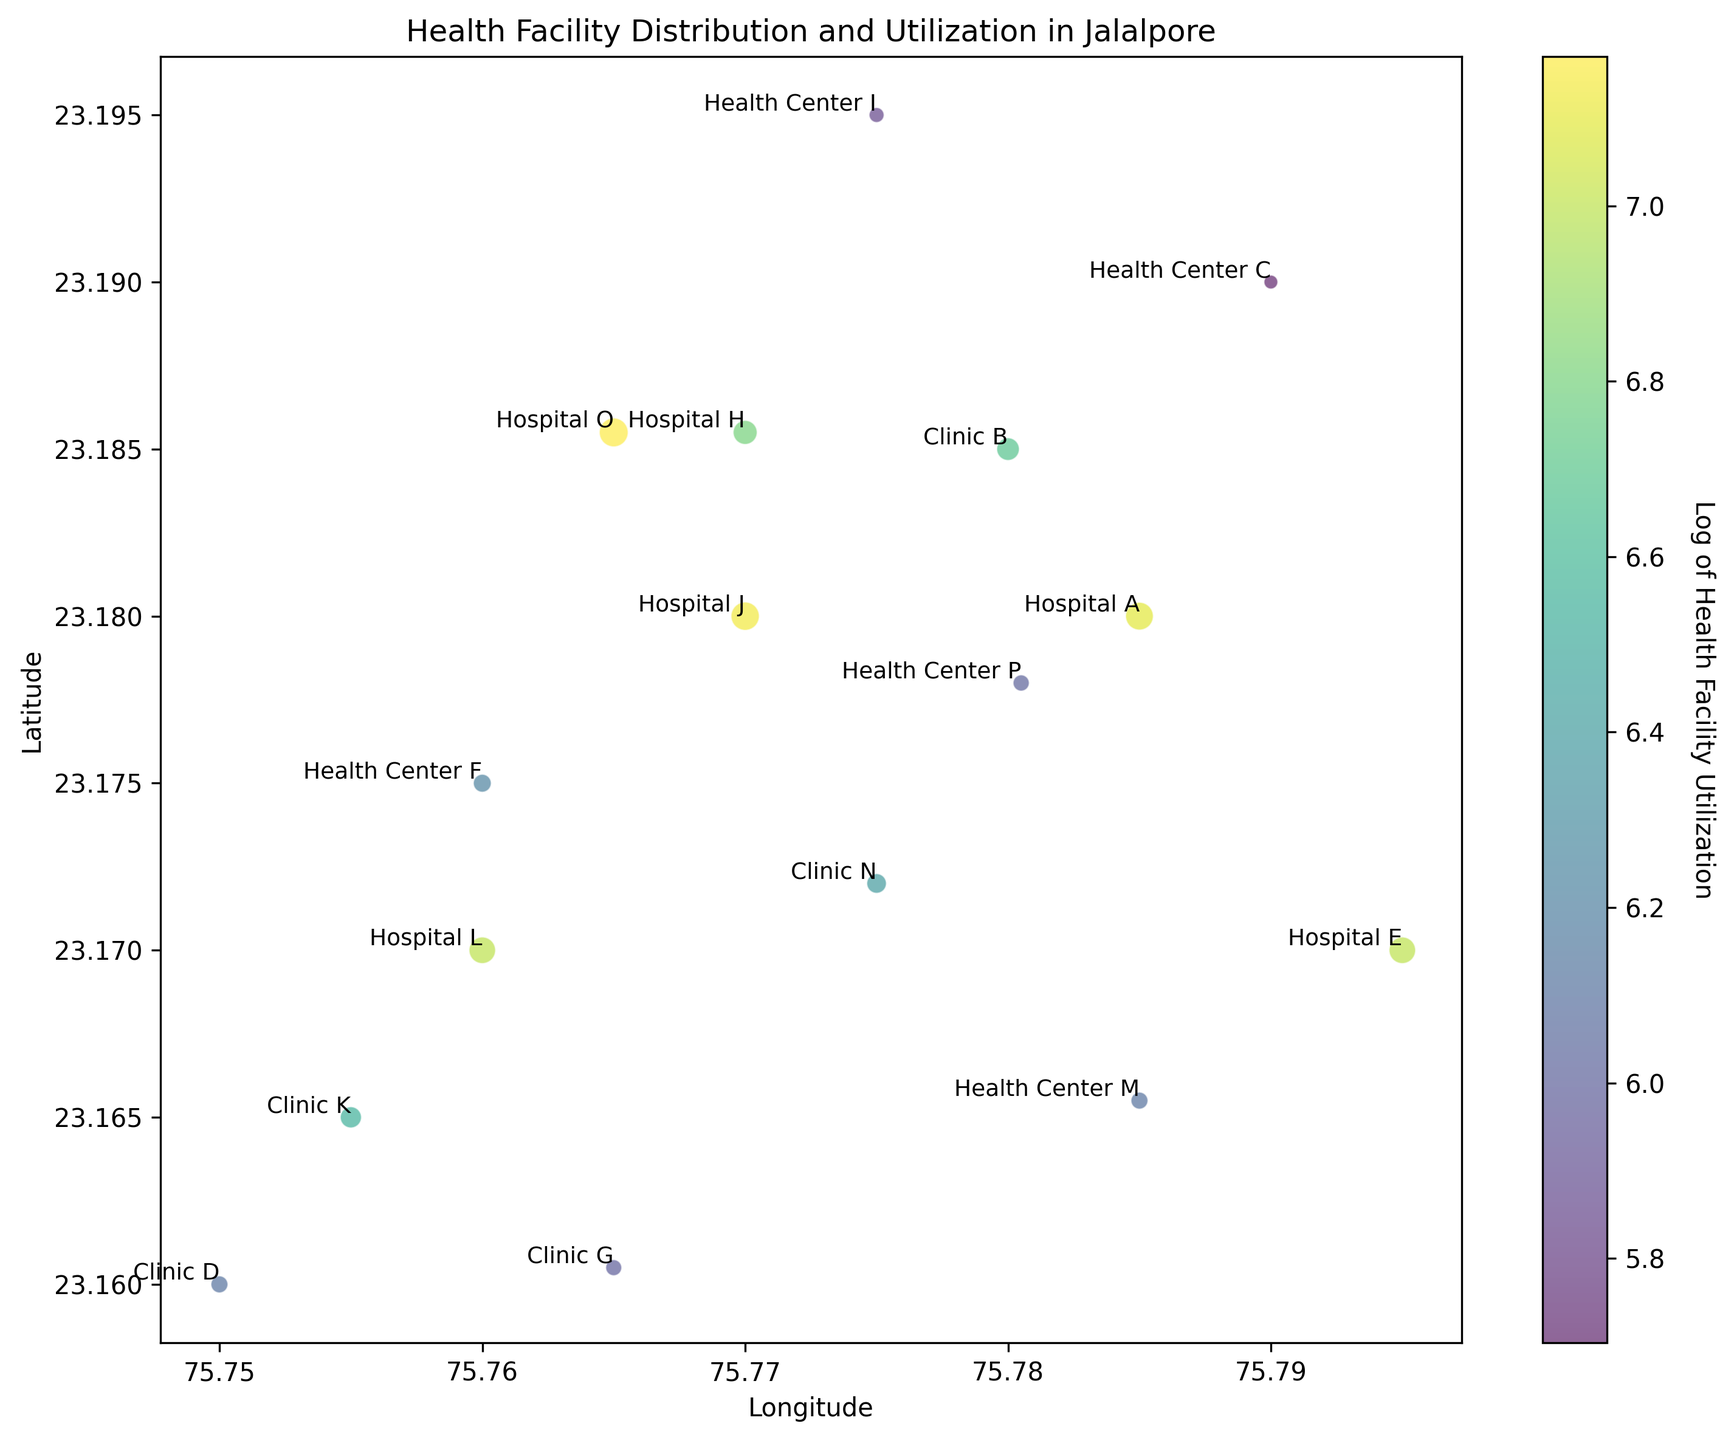What is the range of latitudes covered by the health facilities? To find the range, identify the lowest and highest latitude values from the facilities. The lowest latitude is 23.1600 (Clinic D) and the highest is 23.1950 (Health Center I). The range is 23.1950 - 23.1600 = 0.035
Answer: 0.035 Which facility has the highest utilization? Look for the facility with the largest circle and a color indicating the highest utilization on the heatmap. Hospital O has the highest utilization at 1300.
Answer: Hospital O How do Hospital A and Clinic B compare in terms of utilization? Find the circles representing Hospital A and Clinic B. Compare their sizes and color intensities. Hospital A has a utilization of 1200, while Clinic B has 800.
Answer: Hospital A has higher utilization than Clinic B What is the average utilization of all health centers? Sum up the utilization values of all health centers (300 + 500 + 350 + 450 + 410 = 2010) and divide by the number of health centers (5). The average utilization is 2010 / 5 = 402.
Answer: 402 Which health center has the lowest utilization? Identify the health centers and their color intensities. Health Center C has the lowest utilization of 300.
Answer: Health Center C What is the combined utilization of Hospitals E and J? Sum the utilization values of Hospitals E and J. Hospital E has 1100 and Hospital J has 1250. The combined utilization is 1100 + 1250 = 2350.
Answer: 2350 How does the visualization represent utilization intensity? Look at the scatter plot where varying colors and circle sizes represent utilization. Darker colors and larger circles represent higher utilization.
Answer: By color and size of circles Are there more Clinics or Hospitals on the map? Count the number of Clinics (B, D, G, K, N) and Hospitals (A, E, H, J, L, O). There are 5 Clinics and 6 Hospitals.
Answer: More Hospitals What is the median utilization of the Clinics? List the utilizations of the Clinics (800, 450, 400, 700, 600), sort them (400, 450, 600, 700, 800), and identify the middle value. The median is 600.
Answer: 600 Which facility is located farthest south? Look at the latitudes of all facilities and find the lowest value. Clinic D at 23.1600 is the farthest south.
Answer: Clinic D 